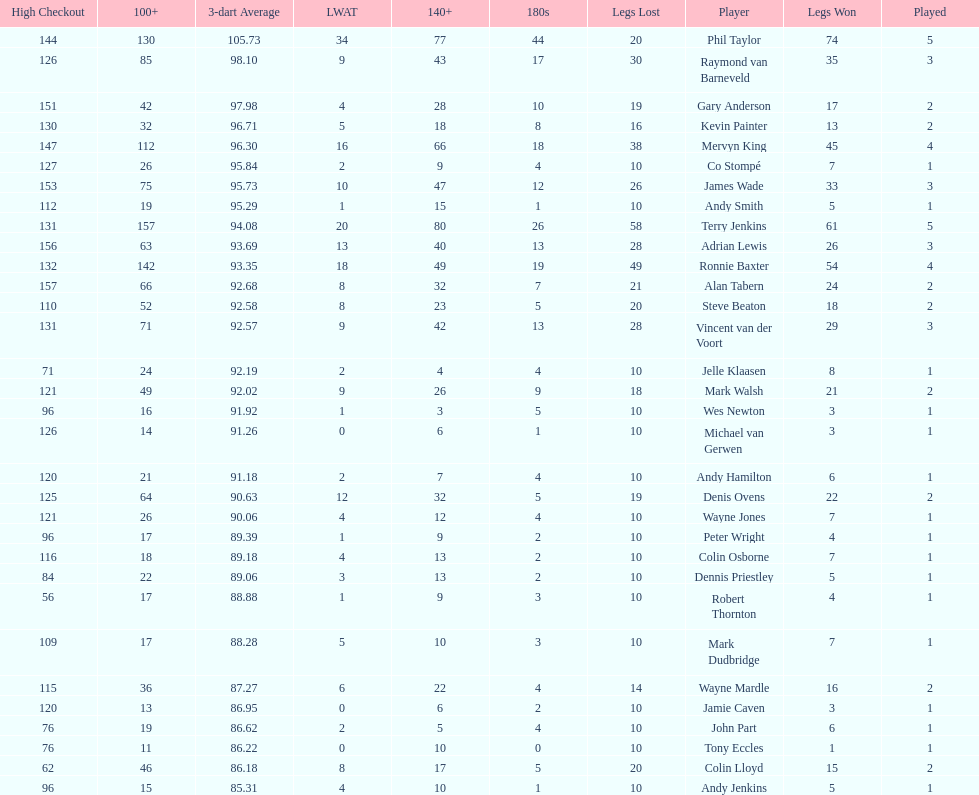Who won the highest number of legs in the 2009 world matchplay? Phil Taylor. 